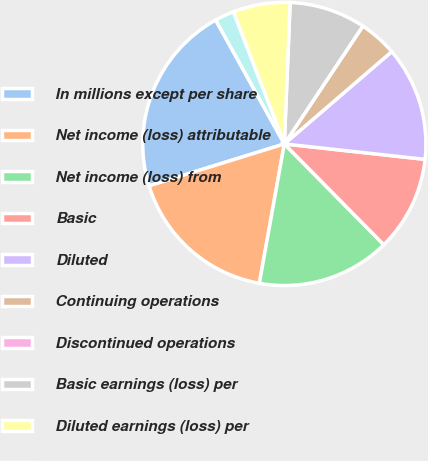<chart> <loc_0><loc_0><loc_500><loc_500><pie_chart><fcel>In millions except per share<fcel>Net income (loss) attributable<fcel>Net income (loss) from<fcel>Basic<fcel>Diluted<fcel>Continuing operations<fcel>Discontinued operations<fcel>Basic earnings (loss) per<fcel>Diluted earnings (loss) per<fcel>Anti-dilutive stock options<nl><fcel>21.74%<fcel>17.39%<fcel>15.22%<fcel>10.87%<fcel>13.04%<fcel>4.35%<fcel>0.0%<fcel>8.7%<fcel>6.52%<fcel>2.18%<nl></chart> 